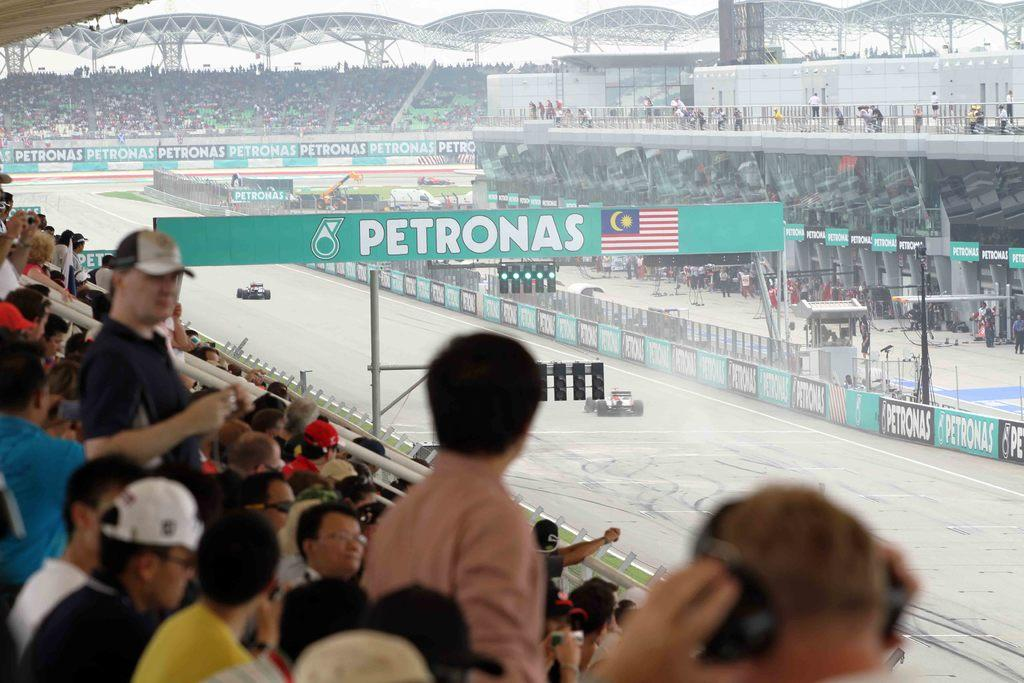What type of vehicles are in the image? There are go-kart cars in the image. Where are the go-kart cars located? The go-kart cars are on a go-kart track. Can you describe the people in the image? There is a group of people in the image. What materials are present in the image? Iron rods and boards are visible in the image. What else can be seen in the image? Lights are present in the image. What is visible in the background of the image? The sky is visible in the background of the image. What type of jewel is being weighed on the scale in the image? There is no scale or jewel present in the image. 